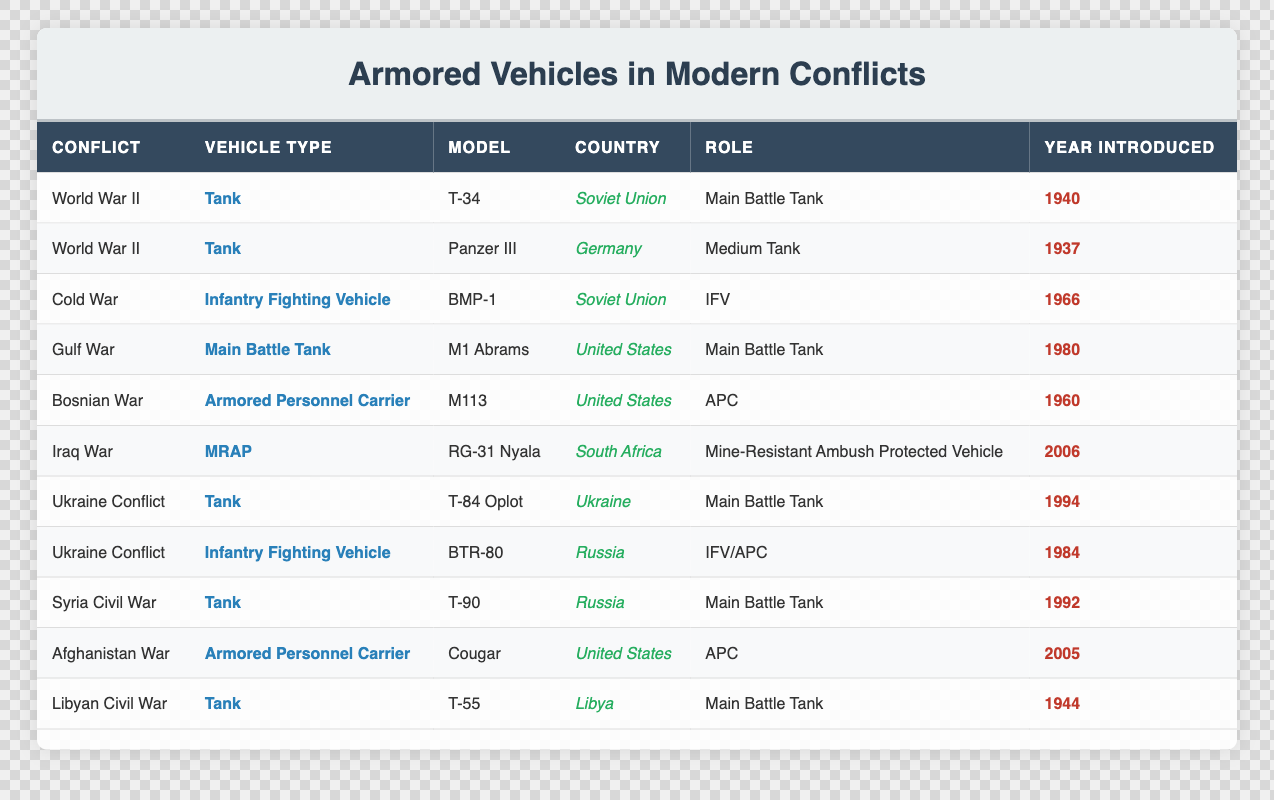What type of armored vehicle was introduced first in World War II? The table lists two armored vehicles from World War II: T-34 and Panzer III. The T-34 was introduced in 1940, while the Panzer III was introduced in 1937. Since 1937 is earlier than 1940, the Panzer III is the first vehicle introduced.
Answer: Panzer III How many armored vehicles were introduced after 2000? Examining the table, the armored vehicles listed after the year 2000 are RG-31 Nyala (2006) and Cougar (2005), making a total of two vehicles.
Answer: 2 Is the T-90 classified as a Main Battle Tank? The table categorizes the T-90 under the column labeled "Role," indicating its type of usage. Since it is listed as a "Main Battle Tank," the answer is clearly affirmed.
Answer: Yes Which country introduced the BMP-1 and what was its vehicle type? Referring to the table, the BMP-1 is listed under the conflict "Cold War," associated with the Soviet Union, and its vehicle type is classified as an Infantry Fighting Vehicle.
Answer: Soviet Union, Infantry Fighting Vehicle Among the listed conflicts, which one has the oldest vehicle introduced? The oldest vehicle based on the year introduced is the Panzer III in 1937. From the table, we can filter through all conflicts to confirm this as the earliest year associated with any vehicle.
Answer: Panzer III in World War II (1937) What is the average year of introduction for all armored vehicles listed? To find the average year of introduction, we sum up the years: 1940, 1937, 1966, 1980, 1960, 2006, 1994, 1984, 1992, 2005, 1944, which totals  2199. This total is then divided by the number of vehicles, which is 11, giving an average of approximately 199.9.
Answer: 1994 Does Ukraine use armored personnel carriers in the current conflict? Inspecting the table shows that the BTR-80 is specified under the "Ukraine Conflict" with the role of IFV/APC, confirming that they do utilize armored personnel carriers.
Answer: Yes Identify the vehicle model introduced in the Gulf War. According to the table, the M1 Abrams is the vehicle type listed under the conflict "Gulf War," and the vehicle model corresponds directly to that conflict.
Answer: M1 Abrams How many different types of vehicles were introduced by the United States? In the table, we can see the US introduced M113 (Armored Personnel Carrier), M1 Abrams (Main Battle Tank), and Cougar (Armored Personnel Carrier) which adds up to three different vehicle types.
Answer: 3 